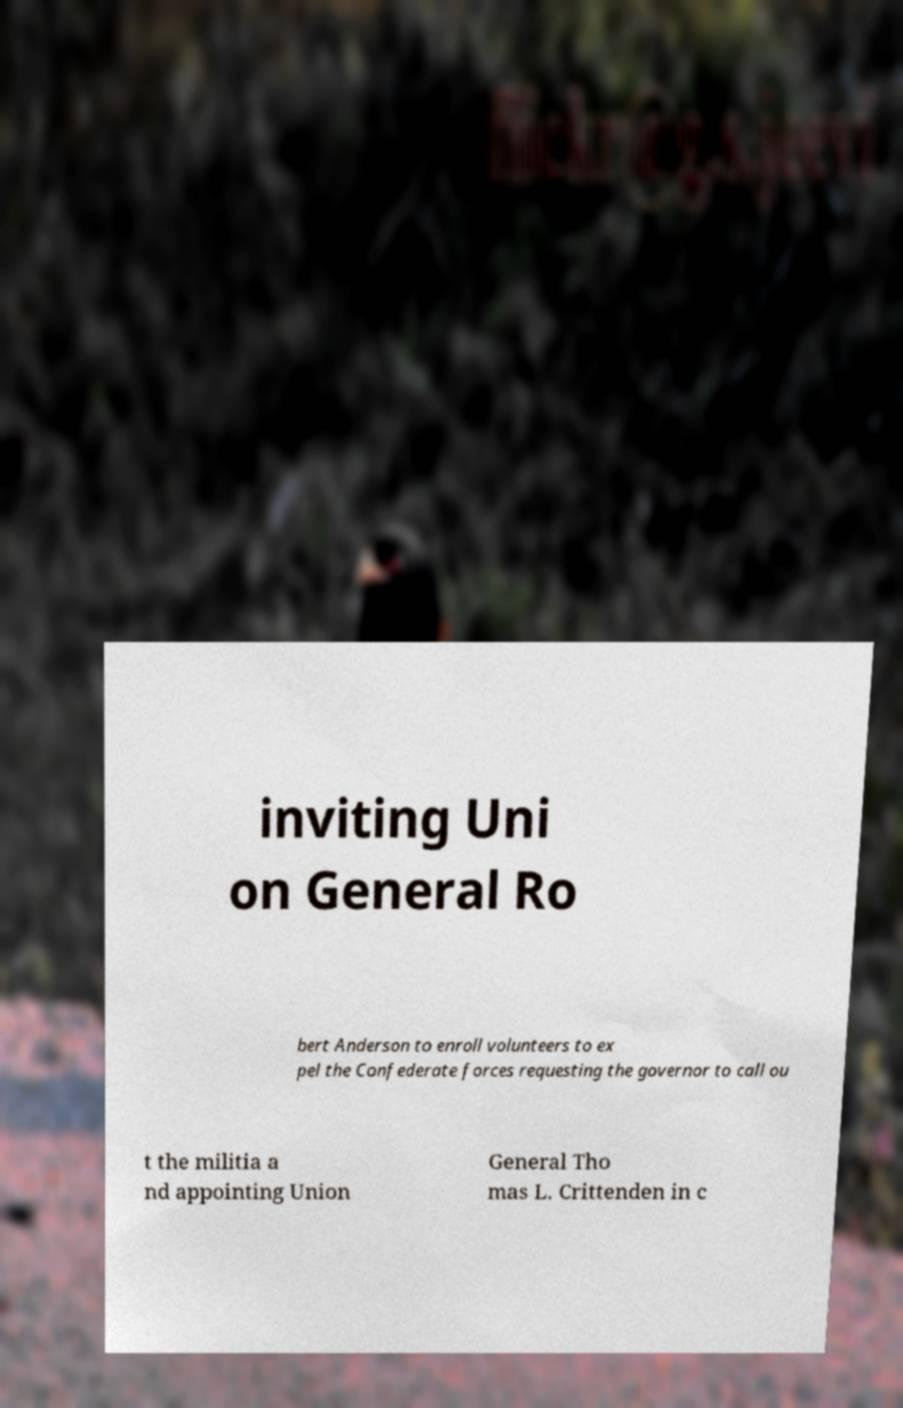Can you read and provide the text displayed in the image?This photo seems to have some interesting text. Can you extract and type it out for me? inviting Uni on General Ro bert Anderson to enroll volunteers to ex pel the Confederate forces requesting the governor to call ou t the militia a nd appointing Union General Tho mas L. Crittenden in c 